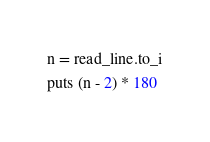Convert code to text. <code><loc_0><loc_0><loc_500><loc_500><_Crystal_>n = read_line.to_i
puts (n - 2) * 180
</code> 